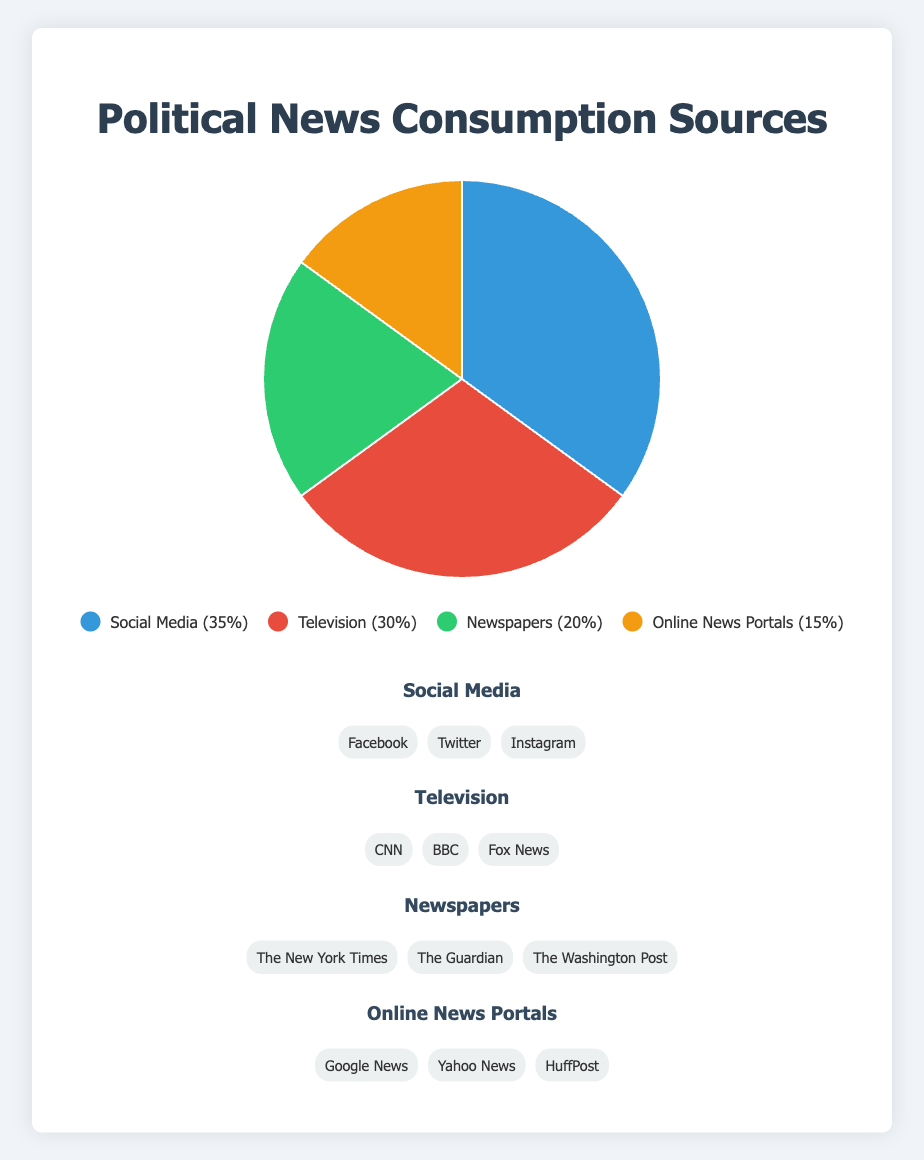Which source is the most significant for political news consumption? The pie chart shows that Social Media has the highest percentage, with 35%.
Answer: Social Media Which two sources combined make up more than half of the political news consumption? Adding the percentages for Social Media (35%) and Television (30%) gives 65%, which is more than half (50%).
Answer: Social Media and Television What is the percentage difference between the most and least popular sources? Social Media has 35%, and Online News Portals have 15%. The difference between them is 35% - 15% = 20%.
Answer: 20% If Newspapers and Online News Portals were combined, what would their total percentage be? Newspapers have 20%, and Online News Portals have 15%. Combined, they would make 20% + 15% = 35%.
Answer: 35% Is Social Media or Television a larger source of political news consumption, and by how much? Social Media (35%) is larger than Television (30%). The difference is 35% - 30% = 5%.
Answer: Social Media by 5% What is the geometric center of the sources in terms of percentage? The sources are Social Media (35%), Television (30%), Newspapers (20%), and Online News Portals (15%). To find the geometric center, we account for the distribution and proportions, identifying Social Media and Television as central since they account for a combined 65%, with Social Media slightly ahead.
Answer: Near Social Media and Television Between Social Media and Newspapers, which has a higher percentage, and what is their combined percentage? Social Media has 35%, and Newspapers have 20%. Social Media is higher, and their combined percentage is 35% + 20% = 55%.
Answer: Social Media, 55% Which source is represented by the green color? The green portion of the chart corresponds to Newspapers, with a percentage of 20%.
Answer: Newspapers How much larger is the percentage of consumption through Television compared to Online News Portals? Television has 30%, and Online News Portals have 15%. The difference is 30% - 15% = 15%.
Answer: 15% If we combine the percentages of all sources, what is the total? Adding the percentages: Social Media (35%) + Television (30%) + Newspapers (20%) + Online News Portals (15%) = 100%.
Answer: 100% 